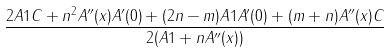<formula> <loc_0><loc_0><loc_500><loc_500>\frac { 2 A 1 C + n ^ { 2 } A ^ { \prime \prime } ( x ) A ^ { \prime } ( 0 ) + ( 2 n - m ) A 1 A ^ { \prime } ( 0 ) + ( m + n ) A ^ { \prime \prime } ( x ) C } { 2 ( A 1 + n A ^ { \prime \prime } ( x ) ) }</formula> 